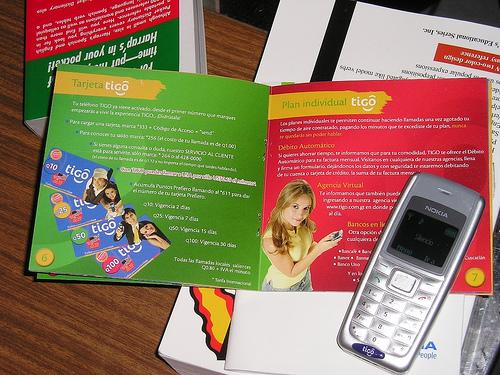What is the silver device on the red paper used for? Please explain your reasoning. making calls. This is a cell phone. 